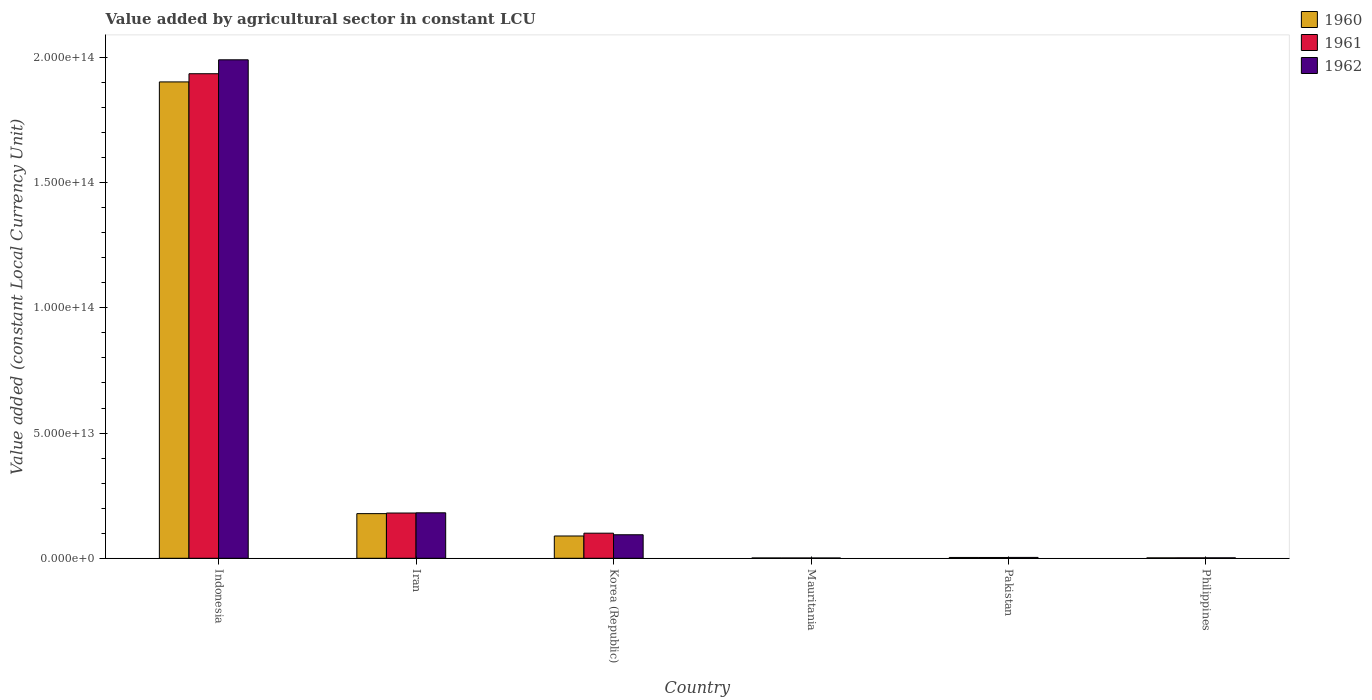How many different coloured bars are there?
Give a very brief answer. 3. How many groups of bars are there?
Ensure brevity in your answer.  6. Are the number of bars per tick equal to the number of legend labels?
Keep it short and to the point. Yes. Are the number of bars on each tick of the X-axis equal?
Give a very brief answer. Yes. How many bars are there on the 1st tick from the right?
Provide a short and direct response. 3. What is the label of the 2nd group of bars from the left?
Your answer should be compact. Iran. What is the value added by agricultural sector in 1962 in Philippines?
Your answer should be very brief. 1.81e+11. Across all countries, what is the maximum value added by agricultural sector in 1960?
Offer a very short reply. 1.90e+14. Across all countries, what is the minimum value added by agricultural sector in 1962?
Your answer should be very brief. 1.20e+11. In which country was the value added by agricultural sector in 1962 minimum?
Give a very brief answer. Mauritania. What is the total value added by agricultural sector in 1961 in the graph?
Provide a short and direct response. 2.22e+14. What is the difference between the value added by agricultural sector in 1961 in Korea (Republic) and that in Mauritania?
Provide a succinct answer. 9.90e+12. What is the difference between the value added by agricultural sector in 1961 in Philippines and the value added by agricultural sector in 1962 in Iran?
Your answer should be compact. -1.80e+13. What is the average value added by agricultural sector in 1961 per country?
Provide a short and direct response. 3.70e+13. What is the difference between the value added by agricultural sector of/in 1961 and value added by agricultural sector of/in 1960 in Korea (Republic)?
Offer a terse response. 1.12e+12. What is the ratio of the value added by agricultural sector in 1962 in Mauritania to that in Philippines?
Your answer should be compact. 0.66. Is the difference between the value added by agricultural sector in 1961 in Iran and Korea (Republic) greater than the difference between the value added by agricultural sector in 1960 in Iran and Korea (Republic)?
Make the answer very short. No. What is the difference between the highest and the second highest value added by agricultural sector in 1962?
Ensure brevity in your answer.  -8.77e+12. What is the difference between the highest and the lowest value added by agricultural sector in 1961?
Provide a succinct answer. 1.93e+14. In how many countries, is the value added by agricultural sector in 1960 greater than the average value added by agricultural sector in 1960 taken over all countries?
Make the answer very short. 1. What does the 1st bar from the left in Philippines represents?
Offer a terse response. 1960. What does the 3rd bar from the right in Pakistan represents?
Ensure brevity in your answer.  1960. Is it the case that in every country, the sum of the value added by agricultural sector in 1960 and value added by agricultural sector in 1961 is greater than the value added by agricultural sector in 1962?
Give a very brief answer. Yes. How many countries are there in the graph?
Give a very brief answer. 6. What is the difference between two consecutive major ticks on the Y-axis?
Keep it short and to the point. 5.00e+13. Does the graph contain grids?
Give a very brief answer. No. Where does the legend appear in the graph?
Your response must be concise. Top right. How many legend labels are there?
Offer a very short reply. 3. What is the title of the graph?
Ensure brevity in your answer.  Value added by agricultural sector in constant LCU. Does "1965" appear as one of the legend labels in the graph?
Keep it short and to the point. No. What is the label or title of the Y-axis?
Keep it short and to the point. Value added (constant Local Currency Unit). What is the Value added (constant Local Currency Unit) of 1960 in Indonesia?
Your answer should be very brief. 1.90e+14. What is the Value added (constant Local Currency Unit) in 1961 in Indonesia?
Provide a short and direct response. 1.94e+14. What is the Value added (constant Local Currency Unit) of 1962 in Indonesia?
Your response must be concise. 1.99e+14. What is the Value added (constant Local Currency Unit) of 1960 in Iran?
Your answer should be compact. 1.78e+13. What is the Value added (constant Local Currency Unit) of 1961 in Iran?
Your answer should be compact. 1.81e+13. What is the Value added (constant Local Currency Unit) in 1962 in Iran?
Provide a succinct answer. 1.82e+13. What is the Value added (constant Local Currency Unit) in 1960 in Korea (Republic)?
Offer a terse response. 8.90e+12. What is the Value added (constant Local Currency Unit) in 1961 in Korea (Republic)?
Provide a short and direct response. 1.00e+13. What is the Value added (constant Local Currency Unit) in 1962 in Korea (Republic)?
Keep it short and to the point. 9.39e+12. What is the Value added (constant Local Currency Unit) in 1960 in Mauritania?
Your answer should be compact. 1.27e+11. What is the Value added (constant Local Currency Unit) of 1961 in Mauritania?
Make the answer very short. 1.23e+11. What is the Value added (constant Local Currency Unit) of 1962 in Mauritania?
Keep it short and to the point. 1.20e+11. What is the Value added (constant Local Currency Unit) of 1960 in Pakistan?
Provide a short and direct response. 3.20e+11. What is the Value added (constant Local Currency Unit) in 1961 in Pakistan?
Your response must be concise. 3.19e+11. What is the Value added (constant Local Currency Unit) of 1962 in Pakistan?
Your response must be concise. 3.39e+11. What is the Value added (constant Local Currency Unit) of 1960 in Philippines?
Your response must be concise. 1.62e+11. What is the Value added (constant Local Currency Unit) of 1961 in Philippines?
Provide a short and direct response. 1.73e+11. What is the Value added (constant Local Currency Unit) of 1962 in Philippines?
Offer a very short reply. 1.81e+11. Across all countries, what is the maximum Value added (constant Local Currency Unit) of 1960?
Offer a very short reply. 1.90e+14. Across all countries, what is the maximum Value added (constant Local Currency Unit) of 1961?
Offer a very short reply. 1.94e+14. Across all countries, what is the maximum Value added (constant Local Currency Unit) of 1962?
Provide a short and direct response. 1.99e+14. Across all countries, what is the minimum Value added (constant Local Currency Unit) of 1960?
Make the answer very short. 1.27e+11. Across all countries, what is the minimum Value added (constant Local Currency Unit) in 1961?
Your answer should be compact. 1.23e+11. Across all countries, what is the minimum Value added (constant Local Currency Unit) of 1962?
Offer a very short reply. 1.20e+11. What is the total Value added (constant Local Currency Unit) of 1960 in the graph?
Your answer should be very brief. 2.18e+14. What is the total Value added (constant Local Currency Unit) in 1961 in the graph?
Your answer should be very brief. 2.22e+14. What is the total Value added (constant Local Currency Unit) in 1962 in the graph?
Give a very brief answer. 2.27e+14. What is the difference between the Value added (constant Local Currency Unit) of 1960 in Indonesia and that in Iran?
Your answer should be compact. 1.72e+14. What is the difference between the Value added (constant Local Currency Unit) of 1961 in Indonesia and that in Iran?
Offer a terse response. 1.75e+14. What is the difference between the Value added (constant Local Currency Unit) in 1962 in Indonesia and that in Iran?
Offer a very short reply. 1.81e+14. What is the difference between the Value added (constant Local Currency Unit) of 1960 in Indonesia and that in Korea (Republic)?
Your response must be concise. 1.81e+14. What is the difference between the Value added (constant Local Currency Unit) of 1961 in Indonesia and that in Korea (Republic)?
Your answer should be very brief. 1.83e+14. What is the difference between the Value added (constant Local Currency Unit) in 1962 in Indonesia and that in Korea (Republic)?
Ensure brevity in your answer.  1.90e+14. What is the difference between the Value added (constant Local Currency Unit) in 1960 in Indonesia and that in Mauritania?
Offer a very short reply. 1.90e+14. What is the difference between the Value added (constant Local Currency Unit) in 1961 in Indonesia and that in Mauritania?
Provide a short and direct response. 1.93e+14. What is the difference between the Value added (constant Local Currency Unit) of 1962 in Indonesia and that in Mauritania?
Keep it short and to the point. 1.99e+14. What is the difference between the Value added (constant Local Currency Unit) of 1960 in Indonesia and that in Pakistan?
Offer a very short reply. 1.90e+14. What is the difference between the Value added (constant Local Currency Unit) in 1961 in Indonesia and that in Pakistan?
Offer a terse response. 1.93e+14. What is the difference between the Value added (constant Local Currency Unit) in 1962 in Indonesia and that in Pakistan?
Your answer should be compact. 1.99e+14. What is the difference between the Value added (constant Local Currency Unit) in 1960 in Indonesia and that in Philippines?
Offer a very short reply. 1.90e+14. What is the difference between the Value added (constant Local Currency Unit) of 1961 in Indonesia and that in Philippines?
Offer a very short reply. 1.93e+14. What is the difference between the Value added (constant Local Currency Unit) of 1962 in Indonesia and that in Philippines?
Make the answer very short. 1.99e+14. What is the difference between the Value added (constant Local Currency Unit) of 1960 in Iran and that in Korea (Republic)?
Keep it short and to the point. 8.93e+12. What is the difference between the Value added (constant Local Currency Unit) in 1961 in Iran and that in Korea (Republic)?
Ensure brevity in your answer.  8.05e+12. What is the difference between the Value added (constant Local Currency Unit) of 1962 in Iran and that in Korea (Republic)?
Your response must be concise. 8.77e+12. What is the difference between the Value added (constant Local Currency Unit) in 1960 in Iran and that in Mauritania?
Your response must be concise. 1.77e+13. What is the difference between the Value added (constant Local Currency Unit) in 1961 in Iran and that in Mauritania?
Offer a terse response. 1.79e+13. What is the difference between the Value added (constant Local Currency Unit) of 1962 in Iran and that in Mauritania?
Your answer should be compact. 1.80e+13. What is the difference between the Value added (constant Local Currency Unit) of 1960 in Iran and that in Pakistan?
Give a very brief answer. 1.75e+13. What is the difference between the Value added (constant Local Currency Unit) of 1961 in Iran and that in Pakistan?
Your answer should be very brief. 1.78e+13. What is the difference between the Value added (constant Local Currency Unit) of 1962 in Iran and that in Pakistan?
Your answer should be compact. 1.78e+13. What is the difference between the Value added (constant Local Currency Unit) of 1960 in Iran and that in Philippines?
Your answer should be compact. 1.77e+13. What is the difference between the Value added (constant Local Currency Unit) of 1961 in Iran and that in Philippines?
Provide a succinct answer. 1.79e+13. What is the difference between the Value added (constant Local Currency Unit) of 1962 in Iran and that in Philippines?
Keep it short and to the point. 1.80e+13. What is the difference between the Value added (constant Local Currency Unit) of 1960 in Korea (Republic) and that in Mauritania?
Your answer should be very brief. 8.77e+12. What is the difference between the Value added (constant Local Currency Unit) of 1961 in Korea (Republic) and that in Mauritania?
Your answer should be compact. 9.90e+12. What is the difference between the Value added (constant Local Currency Unit) in 1962 in Korea (Republic) and that in Mauritania?
Your answer should be very brief. 9.27e+12. What is the difference between the Value added (constant Local Currency Unit) in 1960 in Korea (Republic) and that in Pakistan?
Make the answer very short. 8.58e+12. What is the difference between the Value added (constant Local Currency Unit) in 1961 in Korea (Republic) and that in Pakistan?
Your answer should be very brief. 9.70e+12. What is the difference between the Value added (constant Local Currency Unit) in 1962 in Korea (Republic) and that in Pakistan?
Make the answer very short. 9.05e+12. What is the difference between the Value added (constant Local Currency Unit) of 1960 in Korea (Republic) and that in Philippines?
Provide a short and direct response. 8.74e+12. What is the difference between the Value added (constant Local Currency Unit) in 1961 in Korea (Republic) and that in Philippines?
Offer a terse response. 9.85e+12. What is the difference between the Value added (constant Local Currency Unit) of 1962 in Korea (Republic) and that in Philippines?
Give a very brief answer. 9.21e+12. What is the difference between the Value added (constant Local Currency Unit) in 1960 in Mauritania and that in Pakistan?
Give a very brief answer. -1.93e+11. What is the difference between the Value added (constant Local Currency Unit) of 1961 in Mauritania and that in Pakistan?
Your answer should be very brief. -1.96e+11. What is the difference between the Value added (constant Local Currency Unit) of 1962 in Mauritania and that in Pakistan?
Your answer should be very brief. -2.20e+11. What is the difference between the Value added (constant Local Currency Unit) of 1960 in Mauritania and that in Philippines?
Ensure brevity in your answer.  -3.47e+1. What is the difference between the Value added (constant Local Currency Unit) in 1961 in Mauritania and that in Philippines?
Offer a very short reply. -4.95e+1. What is the difference between the Value added (constant Local Currency Unit) of 1962 in Mauritania and that in Philippines?
Offer a terse response. -6.11e+1. What is the difference between the Value added (constant Local Currency Unit) in 1960 in Pakistan and that in Philippines?
Your response must be concise. 1.58e+11. What is the difference between the Value added (constant Local Currency Unit) of 1961 in Pakistan and that in Philippines?
Your answer should be compact. 1.47e+11. What is the difference between the Value added (constant Local Currency Unit) of 1962 in Pakistan and that in Philippines?
Offer a terse response. 1.58e+11. What is the difference between the Value added (constant Local Currency Unit) in 1960 in Indonesia and the Value added (constant Local Currency Unit) in 1961 in Iran?
Provide a short and direct response. 1.72e+14. What is the difference between the Value added (constant Local Currency Unit) of 1960 in Indonesia and the Value added (constant Local Currency Unit) of 1962 in Iran?
Ensure brevity in your answer.  1.72e+14. What is the difference between the Value added (constant Local Currency Unit) of 1961 in Indonesia and the Value added (constant Local Currency Unit) of 1962 in Iran?
Ensure brevity in your answer.  1.75e+14. What is the difference between the Value added (constant Local Currency Unit) of 1960 in Indonesia and the Value added (constant Local Currency Unit) of 1961 in Korea (Republic)?
Provide a succinct answer. 1.80e+14. What is the difference between the Value added (constant Local Currency Unit) in 1960 in Indonesia and the Value added (constant Local Currency Unit) in 1962 in Korea (Republic)?
Provide a succinct answer. 1.81e+14. What is the difference between the Value added (constant Local Currency Unit) of 1961 in Indonesia and the Value added (constant Local Currency Unit) of 1962 in Korea (Republic)?
Keep it short and to the point. 1.84e+14. What is the difference between the Value added (constant Local Currency Unit) in 1960 in Indonesia and the Value added (constant Local Currency Unit) in 1961 in Mauritania?
Keep it short and to the point. 1.90e+14. What is the difference between the Value added (constant Local Currency Unit) of 1960 in Indonesia and the Value added (constant Local Currency Unit) of 1962 in Mauritania?
Your response must be concise. 1.90e+14. What is the difference between the Value added (constant Local Currency Unit) in 1961 in Indonesia and the Value added (constant Local Currency Unit) in 1962 in Mauritania?
Ensure brevity in your answer.  1.93e+14. What is the difference between the Value added (constant Local Currency Unit) in 1960 in Indonesia and the Value added (constant Local Currency Unit) in 1961 in Pakistan?
Your answer should be compact. 1.90e+14. What is the difference between the Value added (constant Local Currency Unit) of 1960 in Indonesia and the Value added (constant Local Currency Unit) of 1962 in Pakistan?
Offer a terse response. 1.90e+14. What is the difference between the Value added (constant Local Currency Unit) of 1961 in Indonesia and the Value added (constant Local Currency Unit) of 1962 in Pakistan?
Make the answer very short. 1.93e+14. What is the difference between the Value added (constant Local Currency Unit) in 1960 in Indonesia and the Value added (constant Local Currency Unit) in 1961 in Philippines?
Ensure brevity in your answer.  1.90e+14. What is the difference between the Value added (constant Local Currency Unit) of 1960 in Indonesia and the Value added (constant Local Currency Unit) of 1962 in Philippines?
Ensure brevity in your answer.  1.90e+14. What is the difference between the Value added (constant Local Currency Unit) in 1961 in Indonesia and the Value added (constant Local Currency Unit) in 1962 in Philippines?
Provide a succinct answer. 1.93e+14. What is the difference between the Value added (constant Local Currency Unit) in 1960 in Iran and the Value added (constant Local Currency Unit) in 1961 in Korea (Republic)?
Ensure brevity in your answer.  7.81e+12. What is the difference between the Value added (constant Local Currency Unit) of 1960 in Iran and the Value added (constant Local Currency Unit) of 1962 in Korea (Republic)?
Provide a succinct answer. 8.44e+12. What is the difference between the Value added (constant Local Currency Unit) in 1961 in Iran and the Value added (constant Local Currency Unit) in 1962 in Korea (Republic)?
Offer a terse response. 8.68e+12. What is the difference between the Value added (constant Local Currency Unit) of 1960 in Iran and the Value added (constant Local Currency Unit) of 1961 in Mauritania?
Give a very brief answer. 1.77e+13. What is the difference between the Value added (constant Local Currency Unit) of 1960 in Iran and the Value added (constant Local Currency Unit) of 1962 in Mauritania?
Offer a terse response. 1.77e+13. What is the difference between the Value added (constant Local Currency Unit) in 1961 in Iran and the Value added (constant Local Currency Unit) in 1962 in Mauritania?
Keep it short and to the point. 1.80e+13. What is the difference between the Value added (constant Local Currency Unit) in 1960 in Iran and the Value added (constant Local Currency Unit) in 1961 in Pakistan?
Your answer should be very brief. 1.75e+13. What is the difference between the Value added (constant Local Currency Unit) in 1960 in Iran and the Value added (constant Local Currency Unit) in 1962 in Pakistan?
Your response must be concise. 1.75e+13. What is the difference between the Value added (constant Local Currency Unit) in 1961 in Iran and the Value added (constant Local Currency Unit) in 1962 in Pakistan?
Ensure brevity in your answer.  1.77e+13. What is the difference between the Value added (constant Local Currency Unit) of 1960 in Iran and the Value added (constant Local Currency Unit) of 1961 in Philippines?
Your answer should be compact. 1.77e+13. What is the difference between the Value added (constant Local Currency Unit) of 1960 in Iran and the Value added (constant Local Currency Unit) of 1962 in Philippines?
Provide a short and direct response. 1.76e+13. What is the difference between the Value added (constant Local Currency Unit) in 1961 in Iran and the Value added (constant Local Currency Unit) in 1962 in Philippines?
Offer a terse response. 1.79e+13. What is the difference between the Value added (constant Local Currency Unit) of 1960 in Korea (Republic) and the Value added (constant Local Currency Unit) of 1961 in Mauritania?
Offer a very short reply. 8.77e+12. What is the difference between the Value added (constant Local Currency Unit) of 1960 in Korea (Republic) and the Value added (constant Local Currency Unit) of 1962 in Mauritania?
Make the answer very short. 8.78e+12. What is the difference between the Value added (constant Local Currency Unit) of 1961 in Korea (Republic) and the Value added (constant Local Currency Unit) of 1962 in Mauritania?
Offer a very short reply. 9.90e+12. What is the difference between the Value added (constant Local Currency Unit) of 1960 in Korea (Republic) and the Value added (constant Local Currency Unit) of 1961 in Pakistan?
Make the answer very short. 8.58e+12. What is the difference between the Value added (constant Local Currency Unit) of 1960 in Korea (Republic) and the Value added (constant Local Currency Unit) of 1962 in Pakistan?
Provide a short and direct response. 8.56e+12. What is the difference between the Value added (constant Local Currency Unit) of 1961 in Korea (Republic) and the Value added (constant Local Currency Unit) of 1962 in Pakistan?
Make the answer very short. 9.68e+12. What is the difference between the Value added (constant Local Currency Unit) in 1960 in Korea (Republic) and the Value added (constant Local Currency Unit) in 1961 in Philippines?
Offer a terse response. 8.73e+12. What is the difference between the Value added (constant Local Currency Unit) of 1960 in Korea (Republic) and the Value added (constant Local Currency Unit) of 1962 in Philippines?
Your response must be concise. 8.72e+12. What is the difference between the Value added (constant Local Currency Unit) in 1961 in Korea (Republic) and the Value added (constant Local Currency Unit) in 1962 in Philippines?
Provide a succinct answer. 9.84e+12. What is the difference between the Value added (constant Local Currency Unit) in 1960 in Mauritania and the Value added (constant Local Currency Unit) in 1961 in Pakistan?
Offer a very short reply. -1.92e+11. What is the difference between the Value added (constant Local Currency Unit) in 1960 in Mauritania and the Value added (constant Local Currency Unit) in 1962 in Pakistan?
Offer a very short reply. -2.12e+11. What is the difference between the Value added (constant Local Currency Unit) of 1961 in Mauritania and the Value added (constant Local Currency Unit) of 1962 in Pakistan?
Give a very brief answer. -2.16e+11. What is the difference between the Value added (constant Local Currency Unit) in 1960 in Mauritania and the Value added (constant Local Currency Unit) in 1961 in Philippines?
Your response must be concise. -4.55e+1. What is the difference between the Value added (constant Local Currency Unit) of 1960 in Mauritania and the Value added (constant Local Currency Unit) of 1962 in Philippines?
Offer a terse response. -5.34e+1. What is the difference between the Value added (constant Local Currency Unit) of 1961 in Mauritania and the Value added (constant Local Currency Unit) of 1962 in Philippines?
Provide a succinct answer. -5.74e+1. What is the difference between the Value added (constant Local Currency Unit) of 1960 in Pakistan and the Value added (constant Local Currency Unit) of 1961 in Philippines?
Provide a succinct answer. 1.47e+11. What is the difference between the Value added (constant Local Currency Unit) in 1960 in Pakistan and the Value added (constant Local Currency Unit) in 1962 in Philippines?
Offer a terse response. 1.39e+11. What is the difference between the Value added (constant Local Currency Unit) of 1961 in Pakistan and the Value added (constant Local Currency Unit) of 1962 in Philippines?
Make the answer very short. 1.39e+11. What is the average Value added (constant Local Currency Unit) in 1960 per country?
Provide a succinct answer. 3.63e+13. What is the average Value added (constant Local Currency Unit) of 1961 per country?
Offer a terse response. 3.70e+13. What is the average Value added (constant Local Currency Unit) in 1962 per country?
Give a very brief answer. 3.79e+13. What is the difference between the Value added (constant Local Currency Unit) of 1960 and Value added (constant Local Currency Unit) of 1961 in Indonesia?
Provide a short and direct response. -3.27e+12. What is the difference between the Value added (constant Local Currency Unit) of 1960 and Value added (constant Local Currency Unit) of 1962 in Indonesia?
Provide a succinct answer. -8.83e+12. What is the difference between the Value added (constant Local Currency Unit) of 1961 and Value added (constant Local Currency Unit) of 1962 in Indonesia?
Make the answer very short. -5.56e+12. What is the difference between the Value added (constant Local Currency Unit) in 1960 and Value added (constant Local Currency Unit) in 1961 in Iran?
Give a very brief answer. -2.42e+11. What is the difference between the Value added (constant Local Currency Unit) in 1960 and Value added (constant Local Currency Unit) in 1962 in Iran?
Provide a short and direct response. -3.32e+11. What is the difference between the Value added (constant Local Currency Unit) in 1961 and Value added (constant Local Currency Unit) in 1962 in Iran?
Give a very brief answer. -8.95e+1. What is the difference between the Value added (constant Local Currency Unit) of 1960 and Value added (constant Local Currency Unit) of 1961 in Korea (Republic)?
Your answer should be very brief. -1.12e+12. What is the difference between the Value added (constant Local Currency Unit) in 1960 and Value added (constant Local Currency Unit) in 1962 in Korea (Republic)?
Ensure brevity in your answer.  -4.93e+11. What is the difference between the Value added (constant Local Currency Unit) of 1961 and Value added (constant Local Currency Unit) of 1962 in Korea (Republic)?
Your answer should be compact. 6.31e+11. What is the difference between the Value added (constant Local Currency Unit) of 1960 and Value added (constant Local Currency Unit) of 1961 in Mauritania?
Your answer should be very brief. 4.01e+09. What is the difference between the Value added (constant Local Currency Unit) in 1960 and Value added (constant Local Currency Unit) in 1962 in Mauritania?
Ensure brevity in your answer.  7.67e+09. What is the difference between the Value added (constant Local Currency Unit) in 1961 and Value added (constant Local Currency Unit) in 1962 in Mauritania?
Provide a short and direct response. 3.65e+09. What is the difference between the Value added (constant Local Currency Unit) in 1960 and Value added (constant Local Currency Unit) in 1961 in Pakistan?
Offer a terse response. 6.46e+08. What is the difference between the Value added (constant Local Currency Unit) in 1960 and Value added (constant Local Currency Unit) in 1962 in Pakistan?
Offer a very short reply. -1.91e+1. What is the difference between the Value added (constant Local Currency Unit) in 1961 and Value added (constant Local Currency Unit) in 1962 in Pakistan?
Your answer should be very brief. -1.97e+1. What is the difference between the Value added (constant Local Currency Unit) in 1960 and Value added (constant Local Currency Unit) in 1961 in Philippines?
Your response must be concise. -1.08e+1. What is the difference between the Value added (constant Local Currency Unit) of 1960 and Value added (constant Local Currency Unit) of 1962 in Philippines?
Keep it short and to the point. -1.87e+1. What is the difference between the Value added (constant Local Currency Unit) of 1961 and Value added (constant Local Currency Unit) of 1962 in Philippines?
Offer a very short reply. -7.86e+09. What is the ratio of the Value added (constant Local Currency Unit) in 1960 in Indonesia to that in Iran?
Make the answer very short. 10.67. What is the ratio of the Value added (constant Local Currency Unit) of 1961 in Indonesia to that in Iran?
Your response must be concise. 10.71. What is the ratio of the Value added (constant Local Currency Unit) in 1962 in Indonesia to that in Iran?
Keep it short and to the point. 10.96. What is the ratio of the Value added (constant Local Currency Unit) of 1960 in Indonesia to that in Korea (Republic)?
Offer a very short reply. 21.38. What is the ratio of the Value added (constant Local Currency Unit) in 1961 in Indonesia to that in Korea (Republic)?
Offer a very short reply. 19.31. What is the ratio of the Value added (constant Local Currency Unit) of 1962 in Indonesia to that in Korea (Republic)?
Offer a very short reply. 21.2. What is the ratio of the Value added (constant Local Currency Unit) in 1960 in Indonesia to that in Mauritania?
Offer a terse response. 1494.5. What is the ratio of the Value added (constant Local Currency Unit) of 1961 in Indonesia to that in Mauritania?
Offer a terse response. 1569.7. What is the ratio of the Value added (constant Local Currency Unit) of 1962 in Indonesia to that in Mauritania?
Offer a very short reply. 1664.14. What is the ratio of the Value added (constant Local Currency Unit) of 1960 in Indonesia to that in Pakistan?
Keep it short and to the point. 594.38. What is the ratio of the Value added (constant Local Currency Unit) of 1961 in Indonesia to that in Pakistan?
Your answer should be compact. 605.82. What is the ratio of the Value added (constant Local Currency Unit) in 1962 in Indonesia to that in Pakistan?
Your answer should be compact. 586.95. What is the ratio of the Value added (constant Local Currency Unit) of 1960 in Indonesia to that in Philippines?
Ensure brevity in your answer.  1174.47. What is the ratio of the Value added (constant Local Currency Unit) in 1961 in Indonesia to that in Philippines?
Provide a short and direct response. 1119.74. What is the ratio of the Value added (constant Local Currency Unit) in 1962 in Indonesia to that in Philippines?
Ensure brevity in your answer.  1101.78. What is the ratio of the Value added (constant Local Currency Unit) in 1960 in Iran to that in Korea (Republic)?
Offer a very short reply. 2. What is the ratio of the Value added (constant Local Currency Unit) in 1961 in Iran to that in Korea (Republic)?
Give a very brief answer. 1.8. What is the ratio of the Value added (constant Local Currency Unit) of 1962 in Iran to that in Korea (Republic)?
Your response must be concise. 1.93. What is the ratio of the Value added (constant Local Currency Unit) in 1960 in Iran to that in Mauritania?
Give a very brief answer. 140.05. What is the ratio of the Value added (constant Local Currency Unit) in 1961 in Iran to that in Mauritania?
Make the answer very short. 146.57. What is the ratio of the Value added (constant Local Currency Unit) of 1962 in Iran to that in Mauritania?
Provide a succinct answer. 151.8. What is the ratio of the Value added (constant Local Currency Unit) in 1960 in Iran to that in Pakistan?
Your answer should be compact. 55.7. What is the ratio of the Value added (constant Local Currency Unit) in 1961 in Iran to that in Pakistan?
Provide a short and direct response. 56.57. What is the ratio of the Value added (constant Local Currency Unit) in 1962 in Iran to that in Pakistan?
Offer a very short reply. 53.54. What is the ratio of the Value added (constant Local Currency Unit) in 1960 in Iran to that in Philippines?
Offer a very short reply. 110.06. What is the ratio of the Value added (constant Local Currency Unit) in 1961 in Iran to that in Philippines?
Keep it short and to the point. 104.56. What is the ratio of the Value added (constant Local Currency Unit) of 1962 in Iran to that in Philippines?
Offer a very short reply. 100.5. What is the ratio of the Value added (constant Local Currency Unit) in 1960 in Korea (Republic) to that in Mauritania?
Offer a terse response. 69.9. What is the ratio of the Value added (constant Local Currency Unit) in 1961 in Korea (Republic) to that in Mauritania?
Provide a short and direct response. 81.29. What is the ratio of the Value added (constant Local Currency Unit) of 1962 in Korea (Republic) to that in Mauritania?
Provide a succinct answer. 78.51. What is the ratio of the Value added (constant Local Currency Unit) of 1960 in Korea (Republic) to that in Pakistan?
Offer a very short reply. 27.8. What is the ratio of the Value added (constant Local Currency Unit) in 1961 in Korea (Republic) to that in Pakistan?
Your answer should be compact. 31.38. What is the ratio of the Value added (constant Local Currency Unit) in 1962 in Korea (Republic) to that in Pakistan?
Offer a very short reply. 27.69. What is the ratio of the Value added (constant Local Currency Unit) in 1960 in Korea (Republic) to that in Philippines?
Provide a short and direct response. 54.93. What is the ratio of the Value added (constant Local Currency Unit) in 1961 in Korea (Republic) to that in Philippines?
Ensure brevity in your answer.  57.99. What is the ratio of the Value added (constant Local Currency Unit) in 1962 in Korea (Republic) to that in Philippines?
Give a very brief answer. 51.98. What is the ratio of the Value added (constant Local Currency Unit) in 1960 in Mauritania to that in Pakistan?
Provide a short and direct response. 0.4. What is the ratio of the Value added (constant Local Currency Unit) in 1961 in Mauritania to that in Pakistan?
Your answer should be very brief. 0.39. What is the ratio of the Value added (constant Local Currency Unit) of 1962 in Mauritania to that in Pakistan?
Ensure brevity in your answer.  0.35. What is the ratio of the Value added (constant Local Currency Unit) of 1960 in Mauritania to that in Philippines?
Offer a terse response. 0.79. What is the ratio of the Value added (constant Local Currency Unit) in 1961 in Mauritania to that in Philippines?
Your answer should be compact. 0.71. What is the ratio of the Value added (constant Local Currency Unit) of 1962 in Mauritania to that in Philippines?
Make the answer very short. 0.66. What is the ratio of the Value added (constant Local Currency Unit) of 1960 in Pakistan to that in Philippines?
Your answer should be very brief. 1.98. What is the ratio of the Value added (constant Local Currency Unit) in 1961 in Pakistan to that in Philippines?
Provide a short and direct response. 1.85. What is the ratio of the Value added (constant Local Currency Unit) of 1962 in Pakistan to that in Philippines?
Give a very brief answer. 1.88. What is the difference between the highest and the second highest Value added (constant Local Currency Unit) in 1960?
Give a very brief answer. 1.72e+14. What is the difference between the highest and the second highest Value added (constant Local Currency Unit) in 1961?
Offer a terse response. 1.75e+14. What is the difference between the highest and the second highest Value added (constant Local Currency Unit) of 1962?
Offer a terse response. 1.81e+14. What is the difference between the highest and the lowest Value added (constant Local Currency Unit) in 1960?
Your answer should be very brief. 1.90e+14. What is the difference between the highest and the lowest Value added (constant Local Currency Unit) in 1961?
Ensure brevity in your answer.  1.93e+14. What is the difference between the highest and the lowest Value added (constant Local Currency Unit) of 1962?
Offer a very short reply. 1.99e+14. 